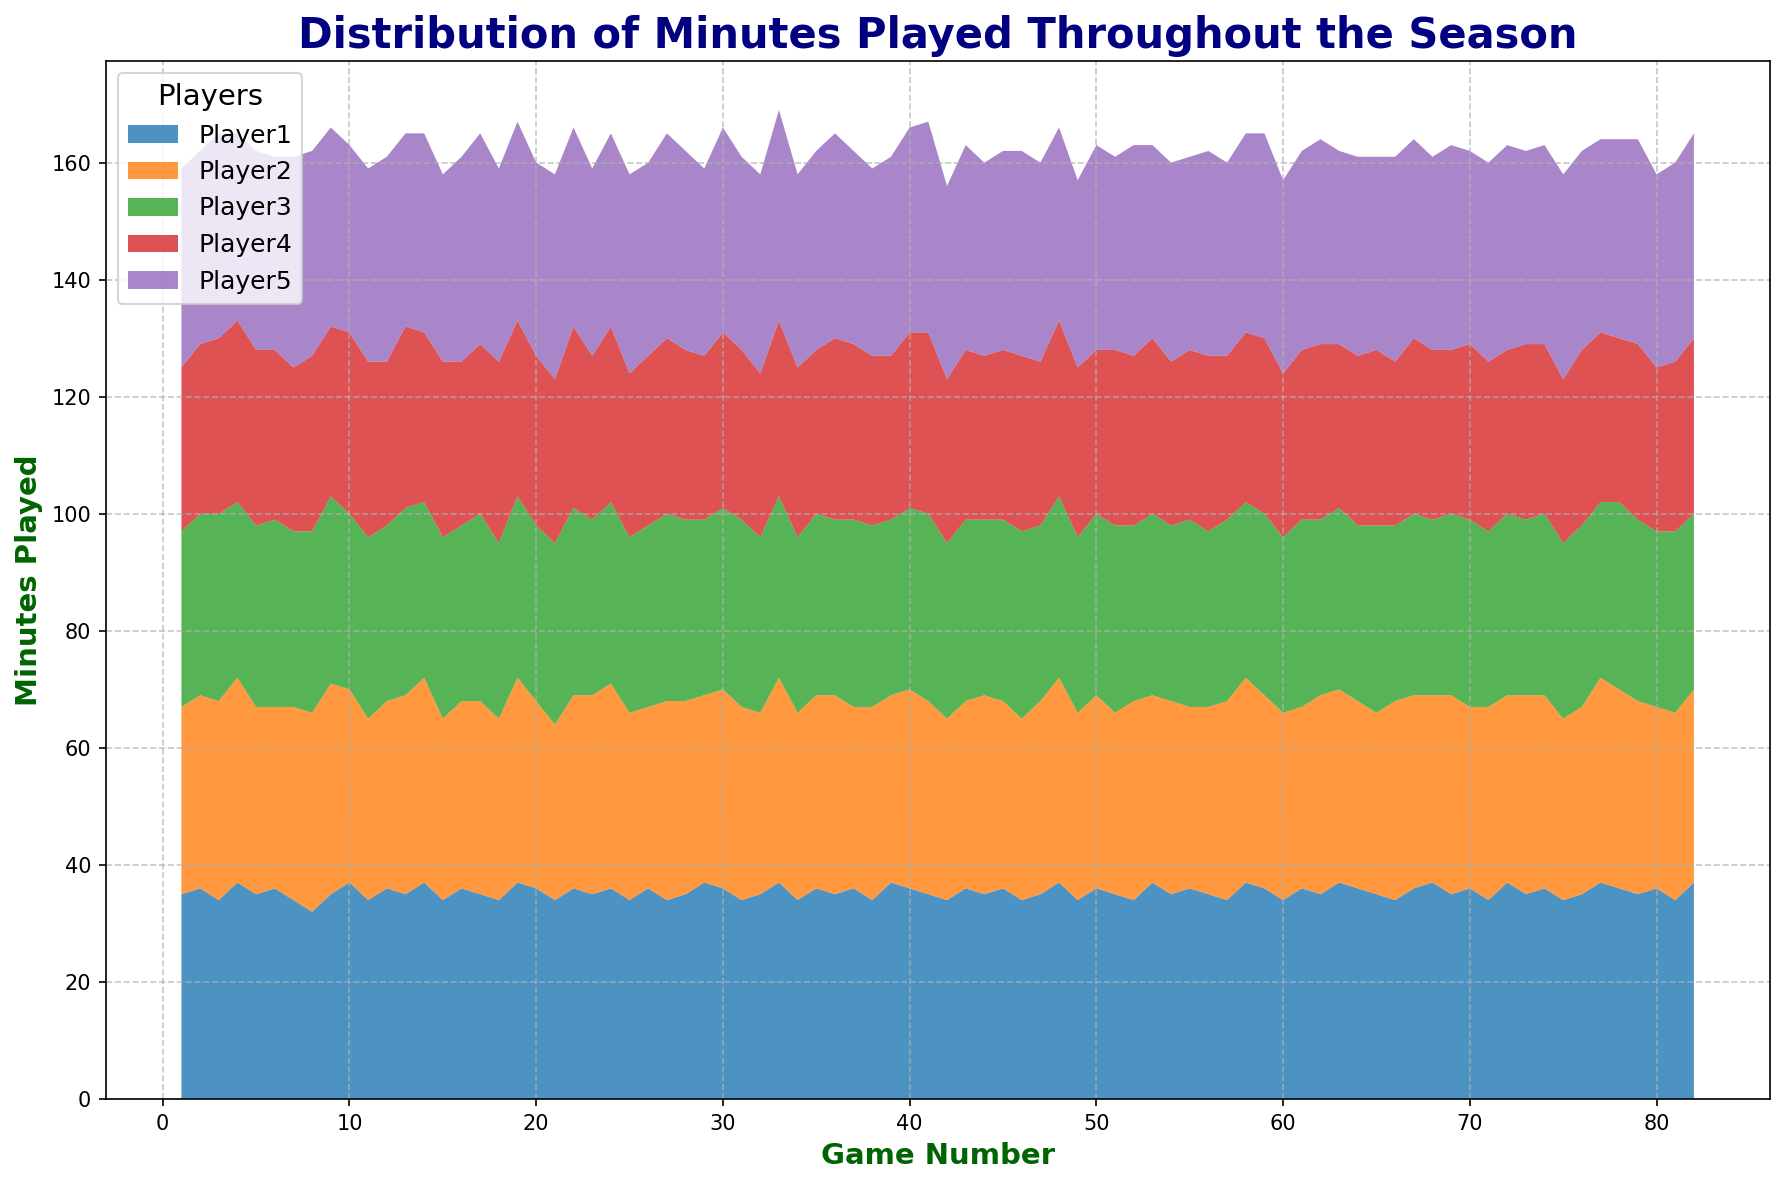What trend can you observe for Player1's minutes over the season? By visually examining the area representing Player1, it generally shows an increasing trend with occasional fluctuations. The area often appears higher, suggesting a higher number of minutes as the games progress.
Answer: Increasing trend How do Player2's and Player4's minutes compare over the season? By comparing the areas for Player2 and Player4, we observe that Player2 generally has a larger area, indicating more minutes played compared to Player4, whose area is consistently lower and more stable throughout the season.
Answer: Player2 > Player4 Which player has the most consistent playtime throughout the season? Visually, Player4's area appears the most consistent in terms of height, meaning their minutes do not vary greatly from game to game. The other players have more variability in the height of their areas.
Answer: Player4 What is the total number of minutes played by Player5 in games 10 to 15? First, sum the Player5's minutes from games 10 to 15: 32 (Game 10) + 33 (Game 11) + 35 (Game 12) + 33 (Game 13) + 34 (Game 14) + 32 (Game 15) = 199.
Answer: 199 On average, which player plays the least minutes across the season? Visually, Player4's area appears to be the smallest and least variable. By averaging the values, Player4 generally falls in the lower range compared to others.
Answer: Player4 During which game does Player2 play the maximum number of minutes? Observe the highest peak in Player2's area. The maximum height occurs in Game 9, where Player2 plays for 36 minutes.
Answer: Game 9 How do Player1's and Player3's minutes compare during the first 5 games of the season? For Player1 and Player3, sum the minutes: Player1 (35+36+34+37+35) = 177, and Player3 (30+31+32+30+31) = 154. Therefore, Player1 has more minutes in the first 5 games than Player3.
Answer: Player1 > Player3 Which game saw the highest total minutes played by all players combined? Sum the minutes for each game across all players and identify the game with the highest total. For Game 33, the sum is: 37 + 35 + 31 + 30 + 36 = 169, which is the highest total observed.
Answer: Game 33 What is the average number of minutes played by Player3 over the entire season? Sum all of Player3's minutes and then divide by the total number of games (82). The total sum is 30+31+32+30+31+32+30+31+32+30+31+30+32+30+31+30+30+31+31+30+31+32+30+31+30+31+32+31+30+31+32+30+31+30+32+30+31+30+32+30+31+30+32+30+31+32+30 = 2490. The average is 2490/82 ≈ 30.37.
Answer: 30.37 At which point in the season does Player1's minutes start to stabilize? Initially, there is fluctuation, but after observing the area, it seems to start stabilizing around Game 20, with fewer extreme variations seen in subsequent games.
Answer: Around Game 20 